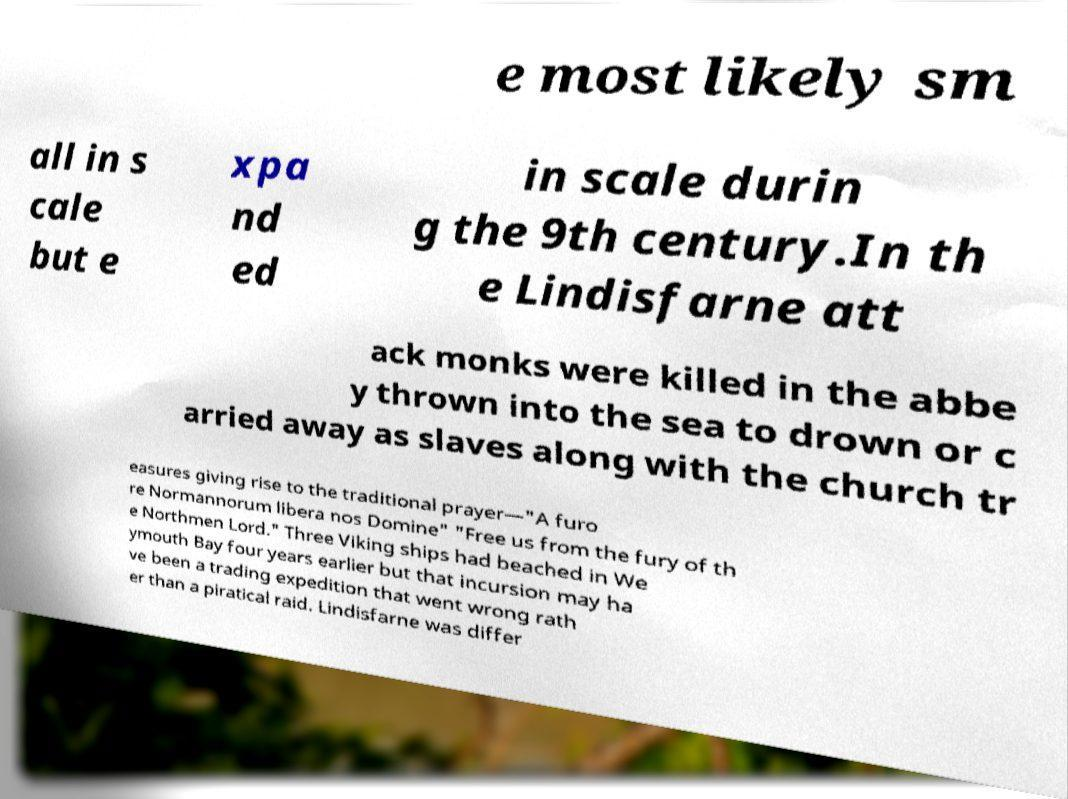What messages or text are displayed in this image? I need them in a readable, typed format. e most likely sm all in s cale but e xpa nd ed in scale durin g the 9th century.In th e Lindisfarne att ack monks were killed in the abbe y thrown into the sea to drown or c arried away as slaves along with the church tr easures giving rise to the traditional prayer—"A furo re Normannorum libera nos Domine" "Free us from the fury of th e Northmen Lord." Three Viking ships had beached in We ymouth Bay four years earlier but that incursion may ha ve been a trading expedition that went wrong rath er than a piratical raid. Lindisfarne was differ 